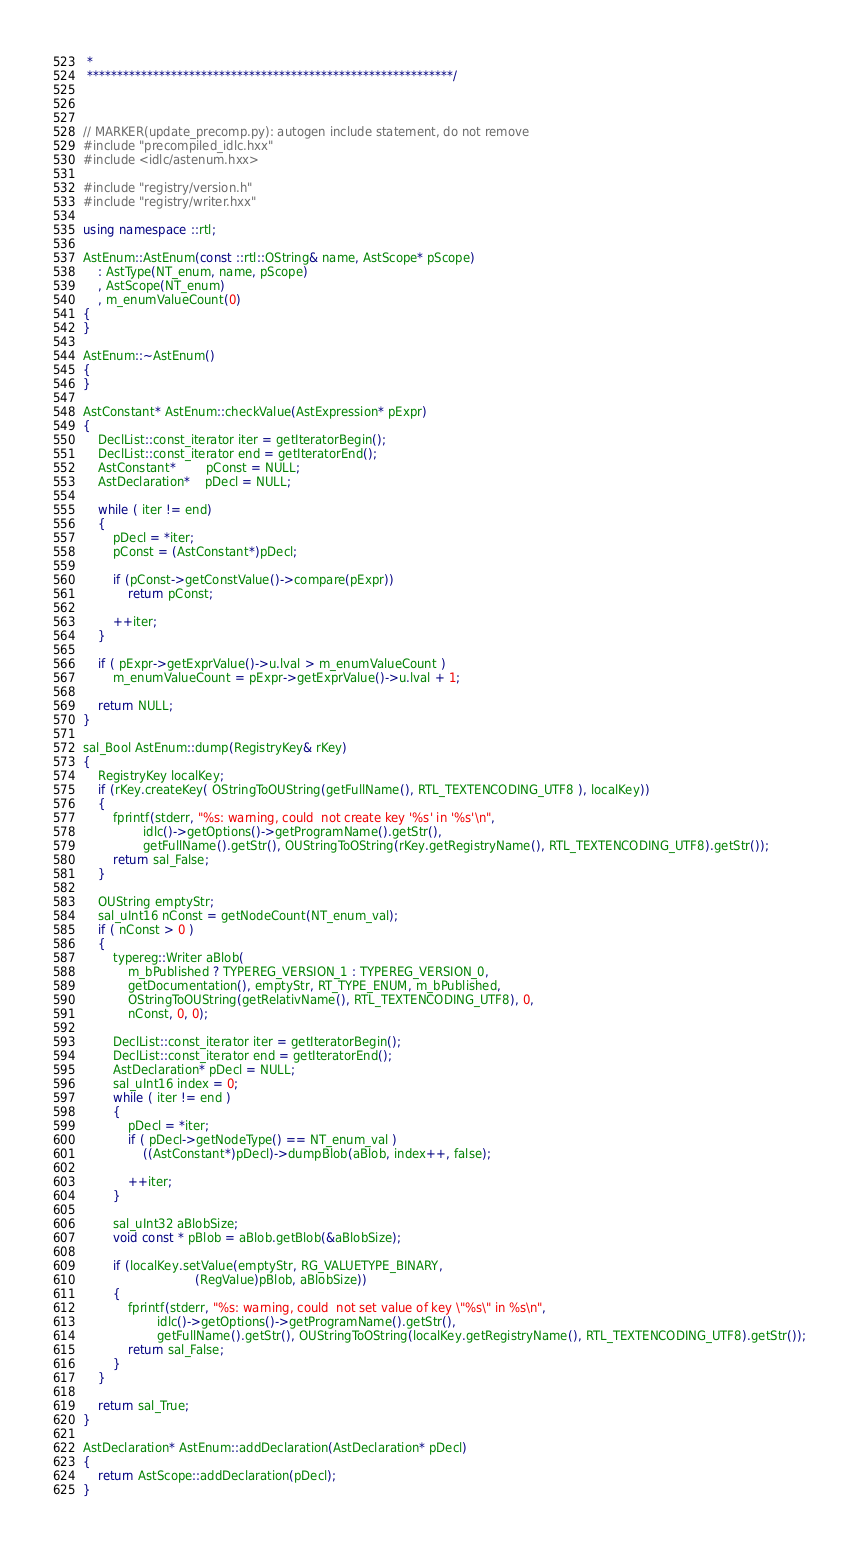Convert code to text. <code><loc_0><loc_0><loc_500><loc_500><_C++_> * 
 *************************************************************/



// MARKER(update_precomp.py): autogen include statement, do not remove
#include "precompiled_idlc.hxx"
#include <idlc/astenum.hxx>

#include "registry/version.h"
#include "registry/writer.hxx"

using namespace ::rtl;

AstEnum::AstEnum(const ::rtl::OString& name, AstScope* pScope)
	: AstType(NT_enum, name, pScope)
	, AstScope(NT_enum)
	, m_enumValueCount(0)
{	
}	

AstEnum::~AstEnum() 
{
}

AstConstant* AstEnum::checkValue(AstExpression* pExpr)
{
	DeclList::const_iterator iter = getIteratorBegin();
	DeclList::const_iterator end = getIteratorEnd();
	AstConstant*		pConst = NULL;
	AstDeclaration* 	pDecl = NULL;

	while ( iter != end) 
	{
		pDecl = *iter;
		pConst = (AstConstant*)pDecl;

		if (pConst->getConstValue()->compare(pExpr)) 
			return pConst;

		++iter;
	}

	if ( pExpr->getExprValue()->u.lval > m_enumValueCount )
		m_enumValueCount = pExpr->getExprValue()->u.lval + 1;

	return NULL;
}	

sal_Bool AstEnum::dump(RegistryKey& rKey)
{
	RegistryKey localKey;
	if (rKey.createKey( OStringToOUString(getFullName(), RTL_TEXTENCODING_UTF8 ), localKey))
	{
		fprintf(stderr, "%s: warning, could	not create key '%s' in '%s'\n",
			    idlc()->getOptions()->getProgramName().getStr(),
			    getFullName().getStr(), OUStringToOString(rKey.getRegistryName(), RTL_TEXTENCODING_UTF8).getStr());
		return sal_False;
	}

    OUString emptyStr;
	sal_uInt16 nConst = getNodeCount(NT_enum_val);
	if ( nConst > 0 )
	{
		typereg::Writer aBlob(
            m_bPublished ? TYPEREG_VERSION_1 : TYPEREG_VERSION_0,
            getDocumentation(), emptyStr, RT_TYPE_ENUM, m_bPublished,
            OStringToOUString(getRelativName(), RTL_TEXTENCODING_UTF8), 0,
            nConst, 0, 0);

		DeclList::const_iterator iter = getIteratorBegin();
		DeclList::const_iterator end = getIteratorEnd();
		AstDeclaration* pDecl = NULL;
		sal_uInt16 index = 0;
		while ( iter != end )
		{
			pDecl = *iter;
			if ( pDecl->getNodeType() == NT_enum_val )
				((AstConstant*)pDecl)->dumpBlob(aBlob, index++, false);

			++iter;
		}

        sal_uInt32 aBlobSize;
        void const * pBlob = aBlob.getBlob(&aBlobSize);
		
		if (localKey.setValue(emptyStr, RG_VALUETYPE_BINARY, 
						  	  (RegValue)pBlob, aBlobSize))
		{
			fprintf(stderr, "%s: warning, could	not set value of key \"%s\" in %s\n",
				    idlc()->getOptions()->getProgramName().getStr(),
					getFullName().getStr(), OUStringToOString(localKey.getRegistryName(), RTL_TEXTENCODING_UTF8).getStr());
			return sal_False;
		}				
	}

	return sal_True;
}	

AstDeclaration* AstEnum::addDeclaration(AstDeclaration* pDecl)
{
	return AstScope::addDeclaration(pDecl);
}	
</code> 